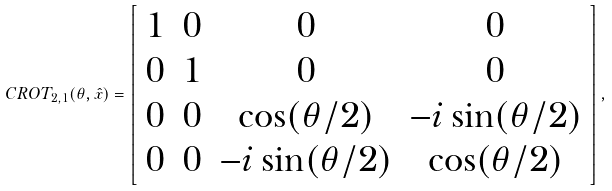Convert formula to latex. <formula><loc_0><loc_0><loc_500><loc_500>C R O T _ { 2 , 1 } ( \theta , \hat { x } ) = \left [ \begin{array} { c c c c } 1 & 0 & 0 & 0 \\ 0 & 1 & 0 & 0 \\ 0 & 0 & \cos ( \theta / 2 ) & - i \sin ( \theta / 2 ) \\ 0 & 0 & - i \sin ( \theta / 2 ) & \cos ( \theta / 2 ) \end{array} \right ] ,</formula> 